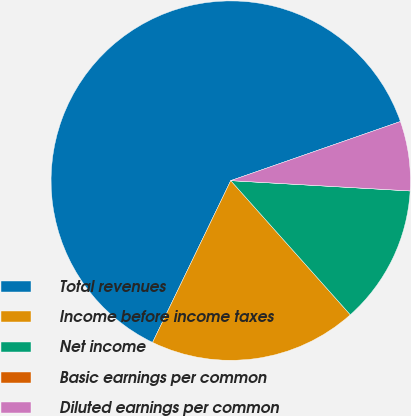Convert chart to OTSL. <chart><loc_0><loc_0><loc_500><loc_500><pie_chart><fcel>Total revenues<fcel>Income before income taxes<fcel>Net income<fcel>Basic earnings per common<fcel>Diluted earnings per common<nl><fcel>62.5%<fcel>18.75%<fcel>12.5%<fcel>0.0%<fcel>6.25%<nl></chart> 